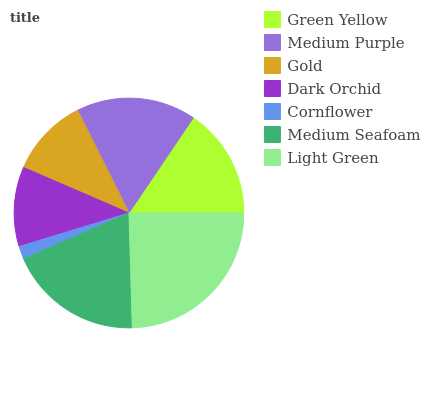Is Cornflower the minimum?
Answer yes or no. Yes. Is Light Green the maximum?
Answer yes or no. Yes. Is Medium Purple the minimum?
Answer yes or no. No. Is Medium Purple the maximum?
Answer yes or no. No. Is Medium Purple greater than Green Yellow?
Answer yes or no. Yes. Is Green Yellow less than Medium Purple?
Answer yes or no. Yes. Is Green Yellow greater than Medium Purple?
Answer yes or no. No. Is Medium Purple less than Green Yellow?
Answer yes or no. No. Is Green Yellow the high median?
Answer yes or no. Yes. Is Green Yellow the low median?
Answer yes or no. Yes. Is Medium Seafoam the high median?
Answer yes or no. No. Is Cornflower the low median?
Answer yes or no. No. 